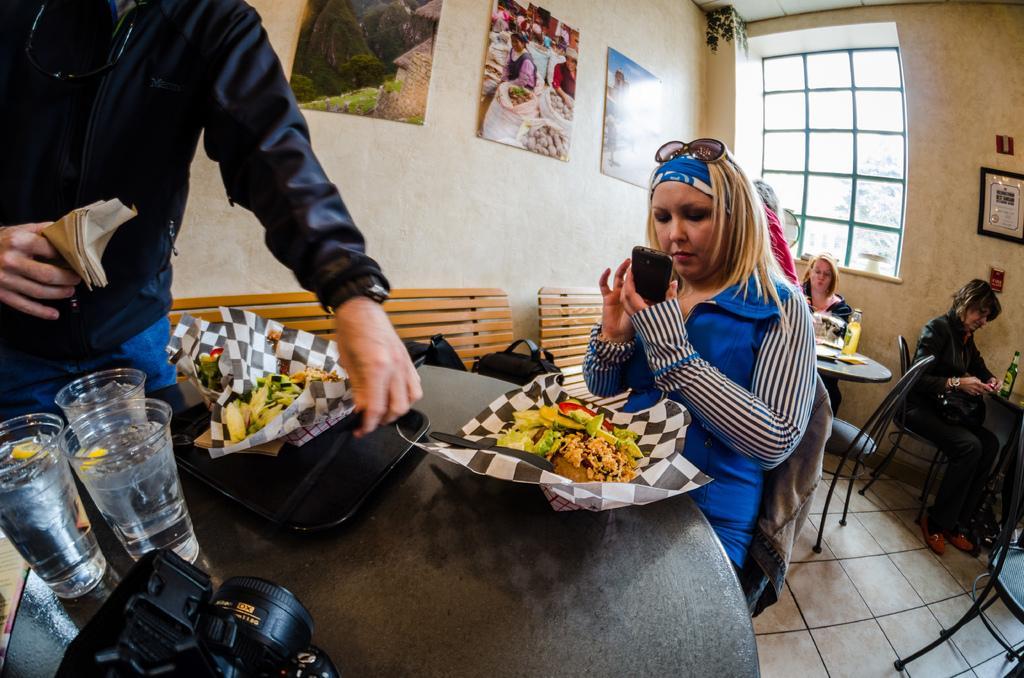Could you give a brief overview of what you see in this image? In this image, There is a table on that table there is a camera in black color and there are some glasses on the table, In the middle there is a woman sitting on the chair and she is holding a mobile which is in black color, In the left side there is a man standing and he is holding a paper, In the background there are some people sitting on the chairs and there is a white color wall and there is a black color window. 